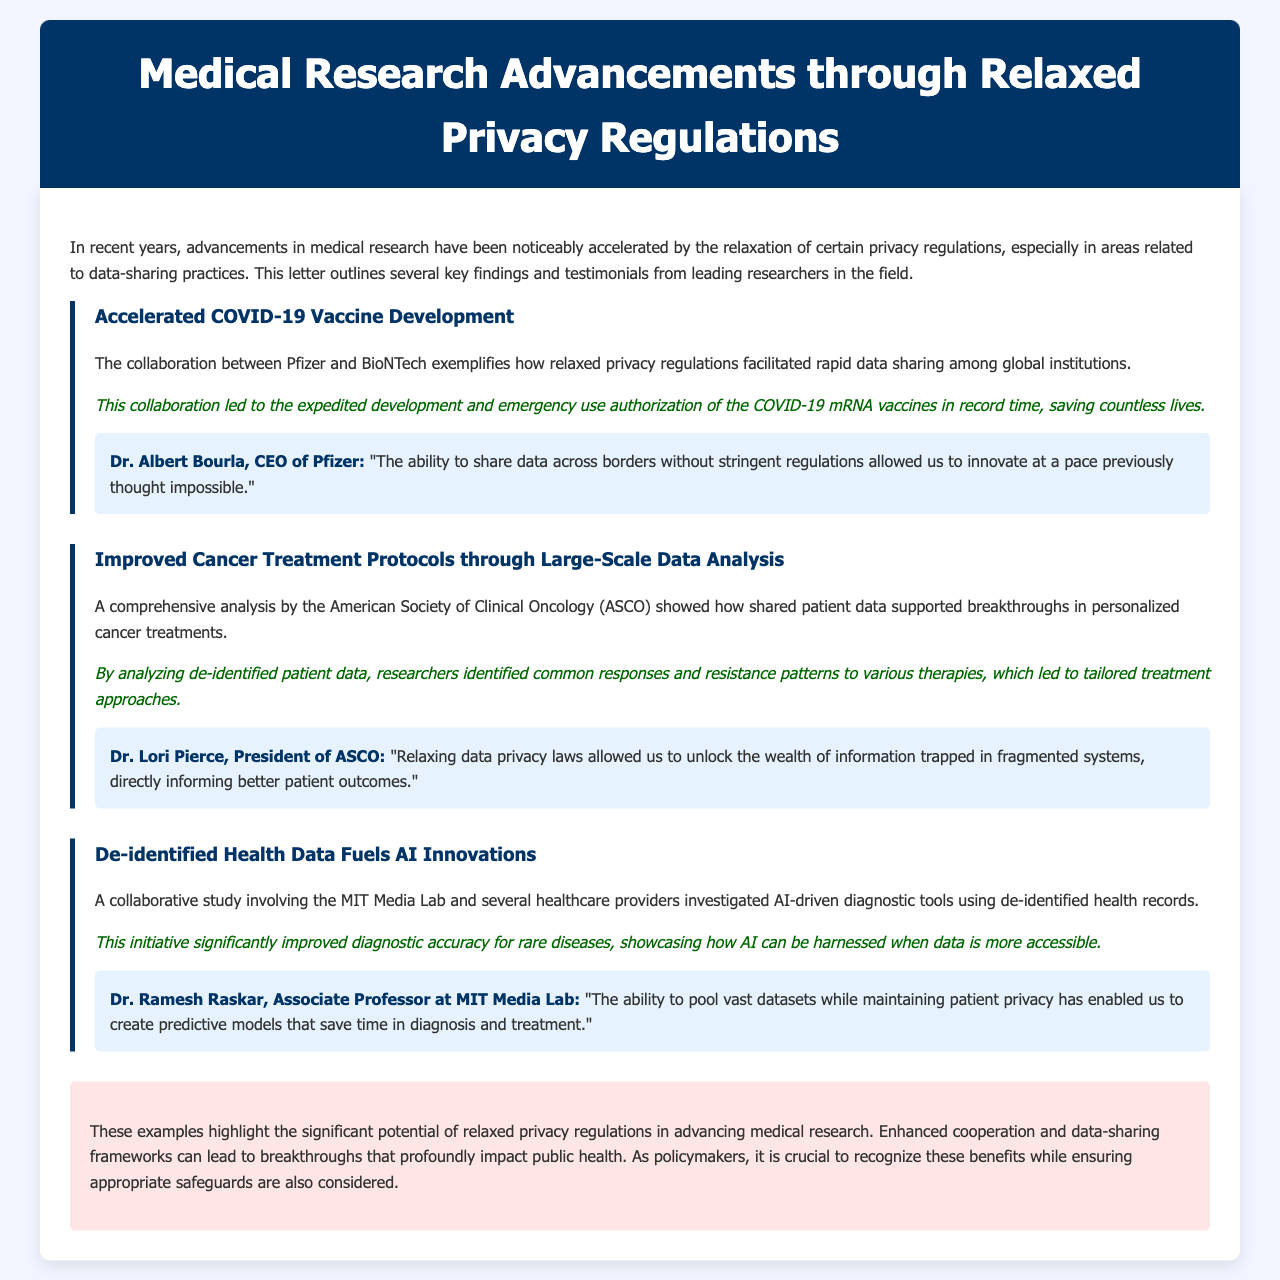What is the main topic of the letter? The letter discusses advancements in medical research through relaxed privacy regulations.
Answer: Advancements in medical research through relaxed privacy regulations Who collaborated to accelerate COVID-19 vaccine development? The letter mentions the collaboration between Pfizer and BioNTech.
Answer: Pfizer and BioNTech How did relaxed privacy regulations impact cancer treatments? The letter states that shared patient data supported breakthroughs in personalized cancer treatments.
Answer: Supported breakthroughs in personalized cancer treatments What is the role of de-identified health data according to the document? The document indicates that de-identified health data fuels AI innovations in diagnostics.
Answer: Fuels AI innovations Which organization's analysis contributed to improvements in cancer treatment protocols? The analysis was conducted by the American Society of Clinical Oncology (ASCO).
Answer: American Society of Clinical Oncology (ASCO) What did Dr. Albert Bourla highlight about data sharing? Dr. Bourla emphasized that data sharing across borders allowed for unprecedented innovation speed.
Answer: Allowed for unprecedented innovation speed What was a consequence of relaxing data privacy laws mentioned by Dr. Lori Pierce? Dr. Pierce noted that it unlocked information from fragmented systems leading to better patient outcomes.
Answer: Better patient outcomes What did Dr. Ramesh Raskar say about predictive models? Dr. Raskar stated that pooling vast datasets enabled the creation of predictive models for diagnosis.
Answer: Creation of predictive models for diagnosis What is emphasized in the conclusion regarding policy considerations? The conclusion emphasizes the importance of recognizing benefits while ensuring appropriate safeguards.
Answer: Recognizing benefits while ensuring appropriate safeguards 